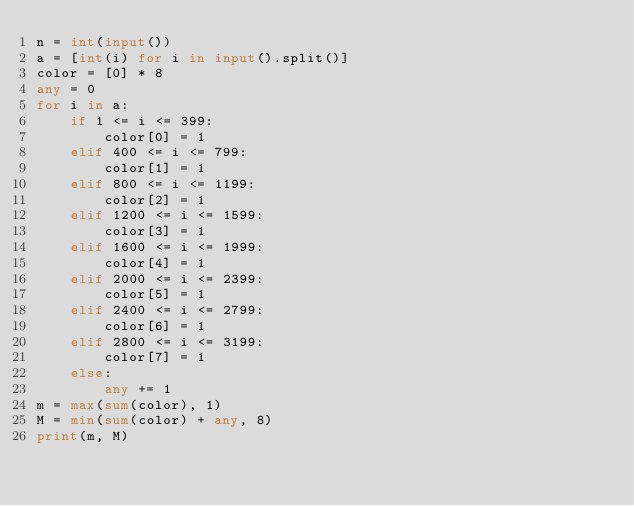Convert code to text. <code><loc_0><loc_0><loc_500><loc_500><_Python_>n = int(input())
a = [int(i) for i in input().split()]
color = [0] * 8
any = 0
for i in a:
    if 1 <= i <= 399:
        color[0] = 1
    elif 400 <= i <= 799:
        color[1] = 1
    elif 800 <= i <= 1199:
        color[2] = 1
    elif 1200 <= i <= 1599:
        color[3] = 1
    elif 1600 <= i <= 1999:
        color[4] = 1
    elif 2000 <= i <= 2399:
        color[5] = 1
    elif 2400 <= i <= 2799:
        color[6] = 1
    elif 2800 <= i <= 3199:
        color[7] = 1
    else:
        any += 1
m = max(sum(color), 1)
M = min(sum(color) + any, 8)
print(m, M)	</code> 